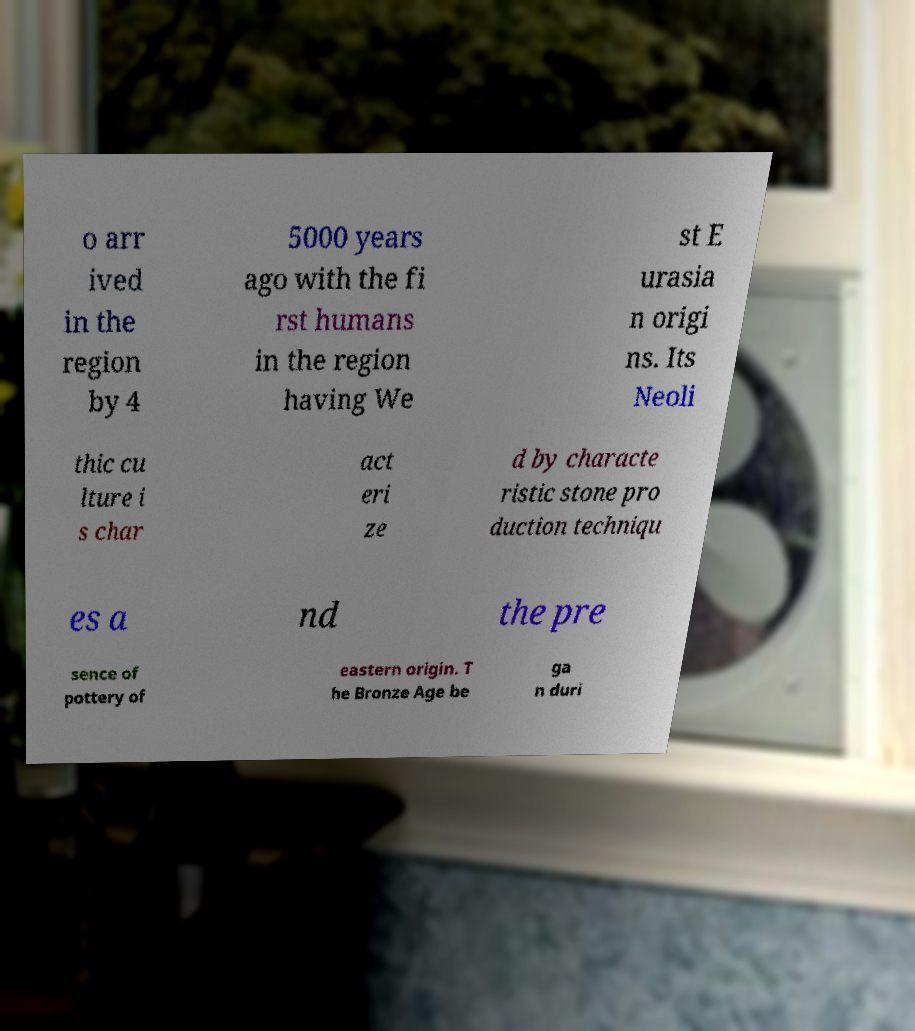What messages or text are displayed in this image? I need them in a readable, typed format. o arr ived in the region by 4 5000 years ago with the fi rst humans in the region having We st E urasia n origi ns. Its Neoli thic cu lture i s char act eri ze d by characte ristic stone pro duction techniqu es a nd the pre sence of pottery of eastern origin. T he Bronze Age be ga n duri 